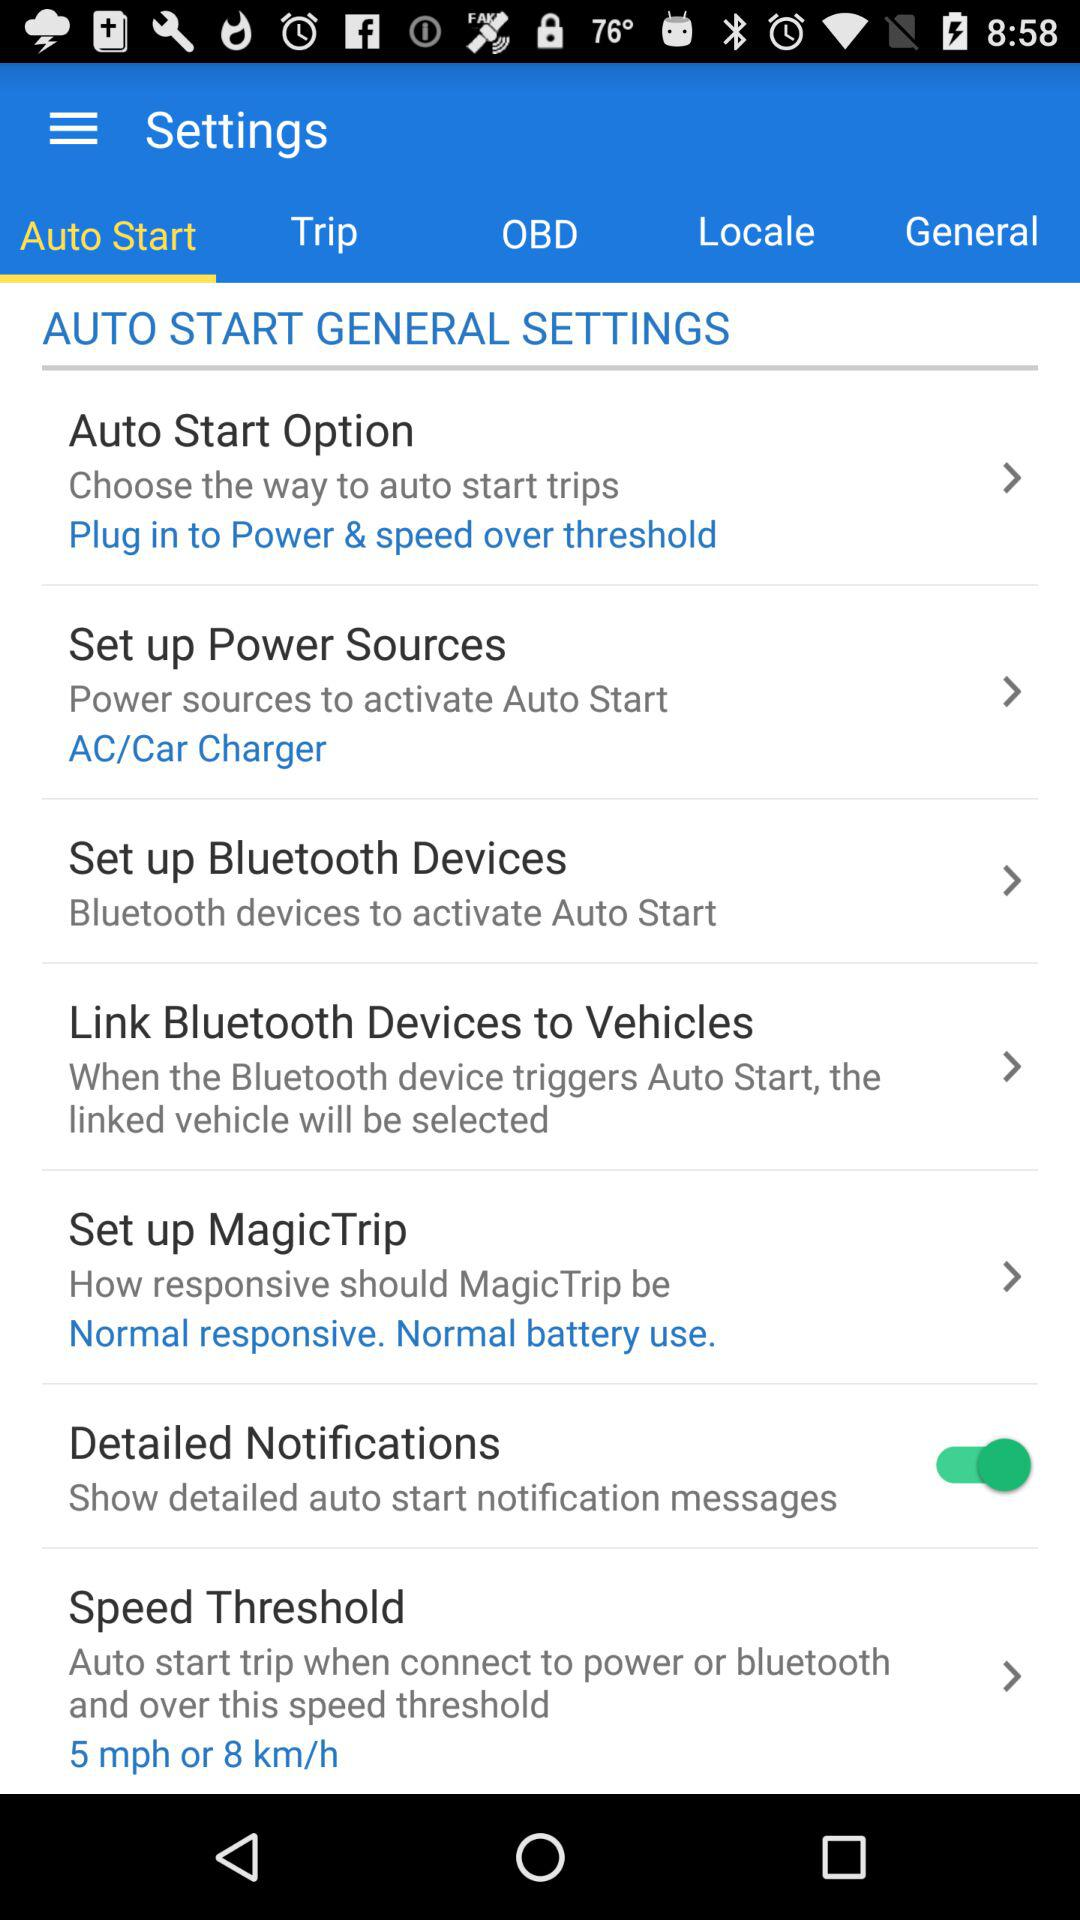What is the status of "Detailed Notifications"? The status of "Detailed Notifications" is "on". 